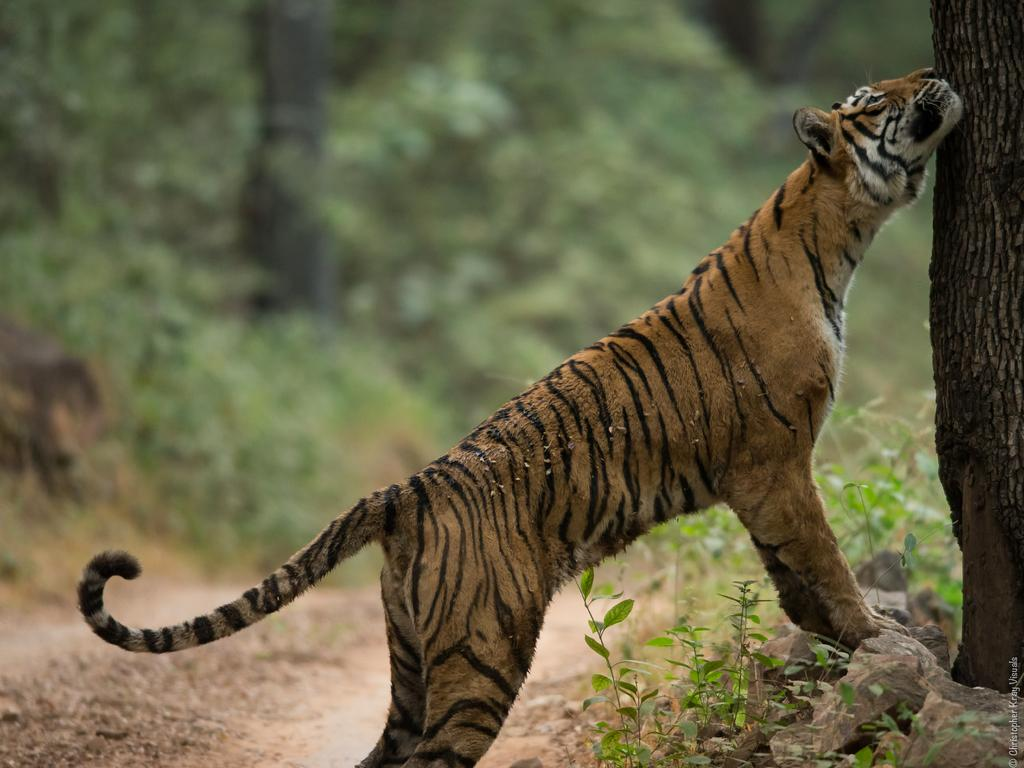What type of animal is in the image? There is a tiger in the image. What else can be seen on the ground in the image? There are stones and plants visible in the image. What is located at the right side of the image? There is a tree trunk at the right side of the image. How would you describe the background of the image? The background of the image is blurred. What type of credit can be seen on the tiger's chin in the image? There is no credit or chin present on the tiger in the image. How does the cannon affect the tiger's movement in the image? There is no cannon present in the image, so it does not affect the tiger's movement. 